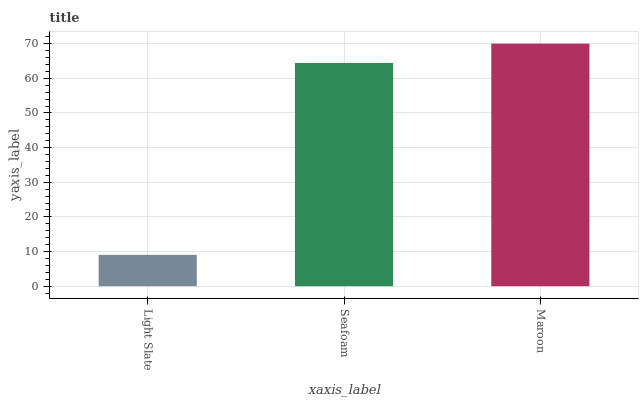Is Seafoam the minimum?
Answer yes or no. No. Is Seafoam the maximum?
Answer yes or no. No. Is Seafoam greater than Light Slate?
Answer yes or no. Yes. Is Light Slate less than Seafoam?
Answer yes or no. Yes. Is Light Slate greater than Seafoam?
Answer yes or no. No. Is Seafoam less than Light Slate?
Answer yes or no. No. Is Seafoam the high median?
Answer yes or no. Yes. Is Seafoam the low median?
Answer yes or no. Yes. Is Light Slate the high median?
Answer yes or no. No. Is Light Slate the low median?
Answer yes or no. No. 